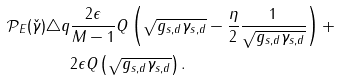<formula> <loc_0><loc_0><loc_500><loc_500>\mathcal { P } _ { E } ( \check { \gamma } ) \triangle q & \frac { 2 \epsilon } { M - 1 } Q \left ( \sqrt { g _ { s , d } \gamma _ { s , d } } - \frac { \eta } { 2 } \frac { 1 } { \sqrt { g _ { s , d } \gamma _ { s , d } } } \right ) + \\ & 2 \epsilon Q \left ( \sqrt { g _ { s , d } \gamma _ { s , d } } \right ) .</formula> 